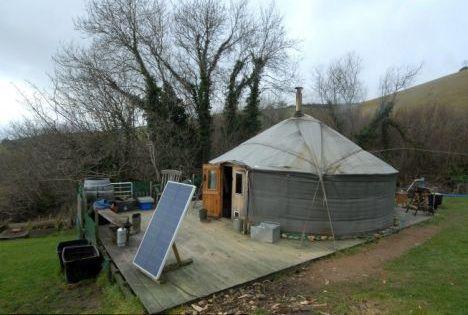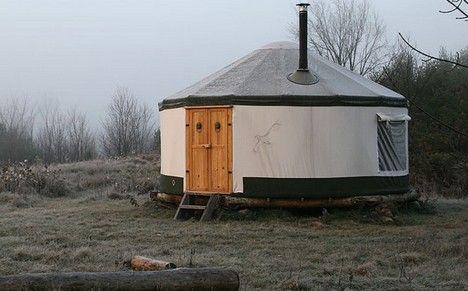The first image is the image on the left, the second image is the image on the right. Evaluate the accuracy of this statement regarding the images: "There is at least one round window in the door in one of the images.". Is it true? Answer yes or no. Yes. 